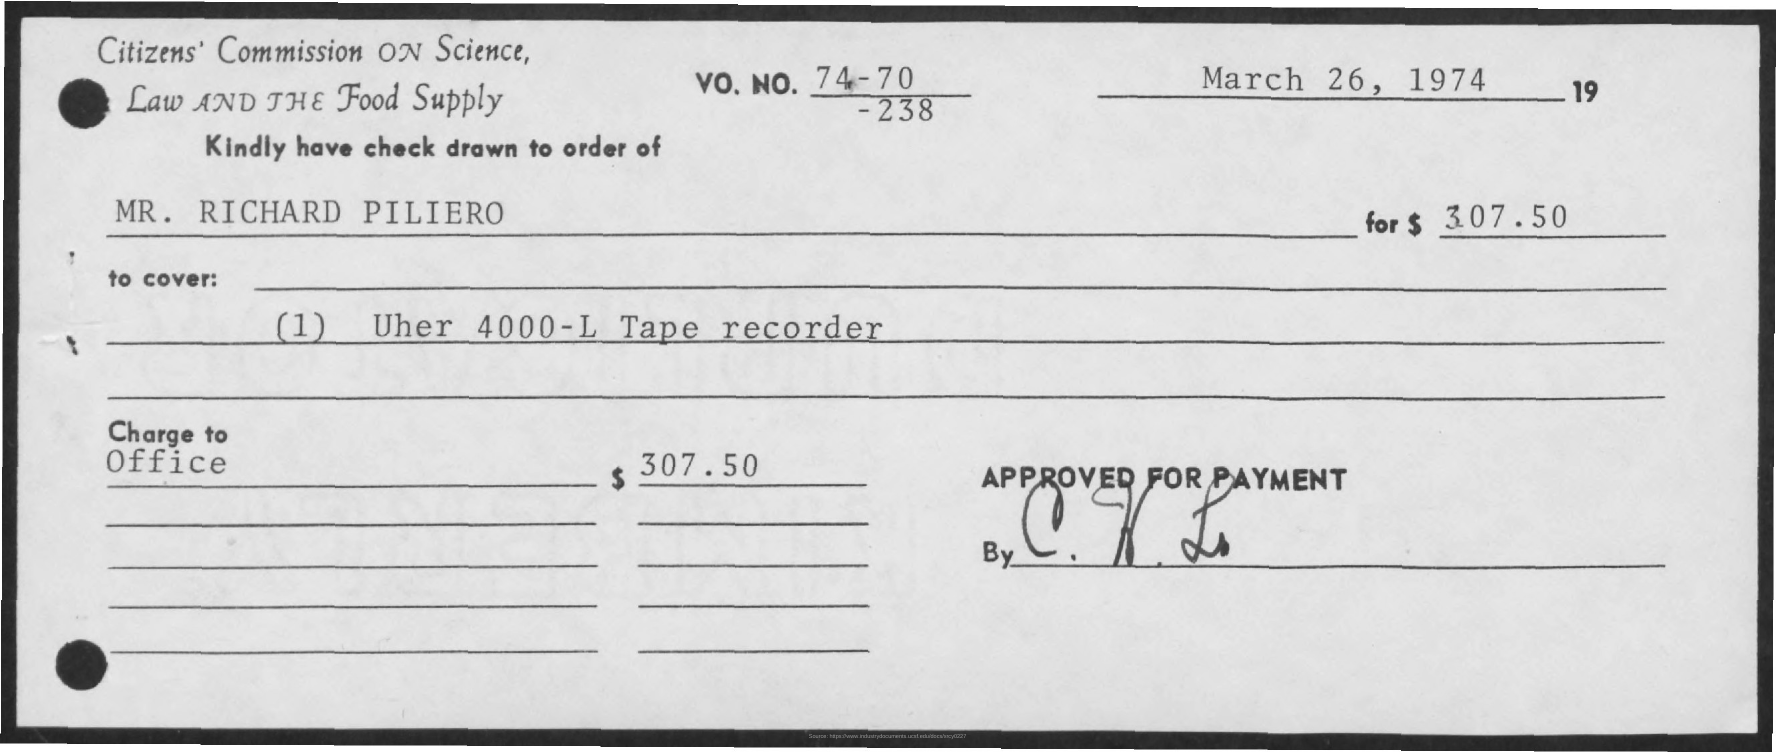What is the date mentioned ?
Offer a very short reply. March 26 , 1974. Whose name is mentioned ?
Make the answer very short. MR. Richard Piliero. How much is the amount mentioned ?
Give a very brief answer. $307.50. What is mentioned in the to cover ?
Provide a succinct answer. (1) Uher 4000-L tape recorder. 